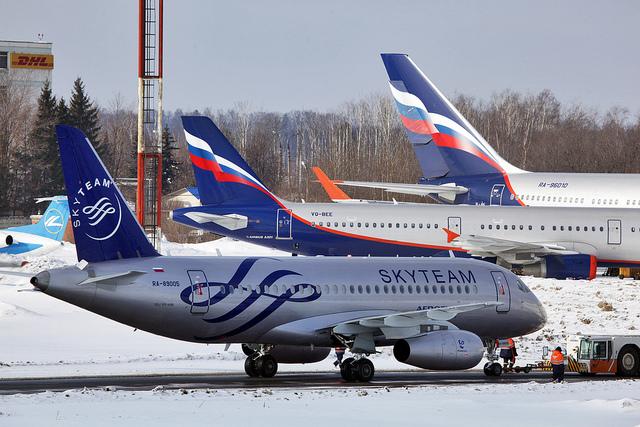What is written on the building?
Concise answer only. Dhl. Are all the planes from the same company?
Write a very short answer. No. What season is it?
Be succinct. Winter. 